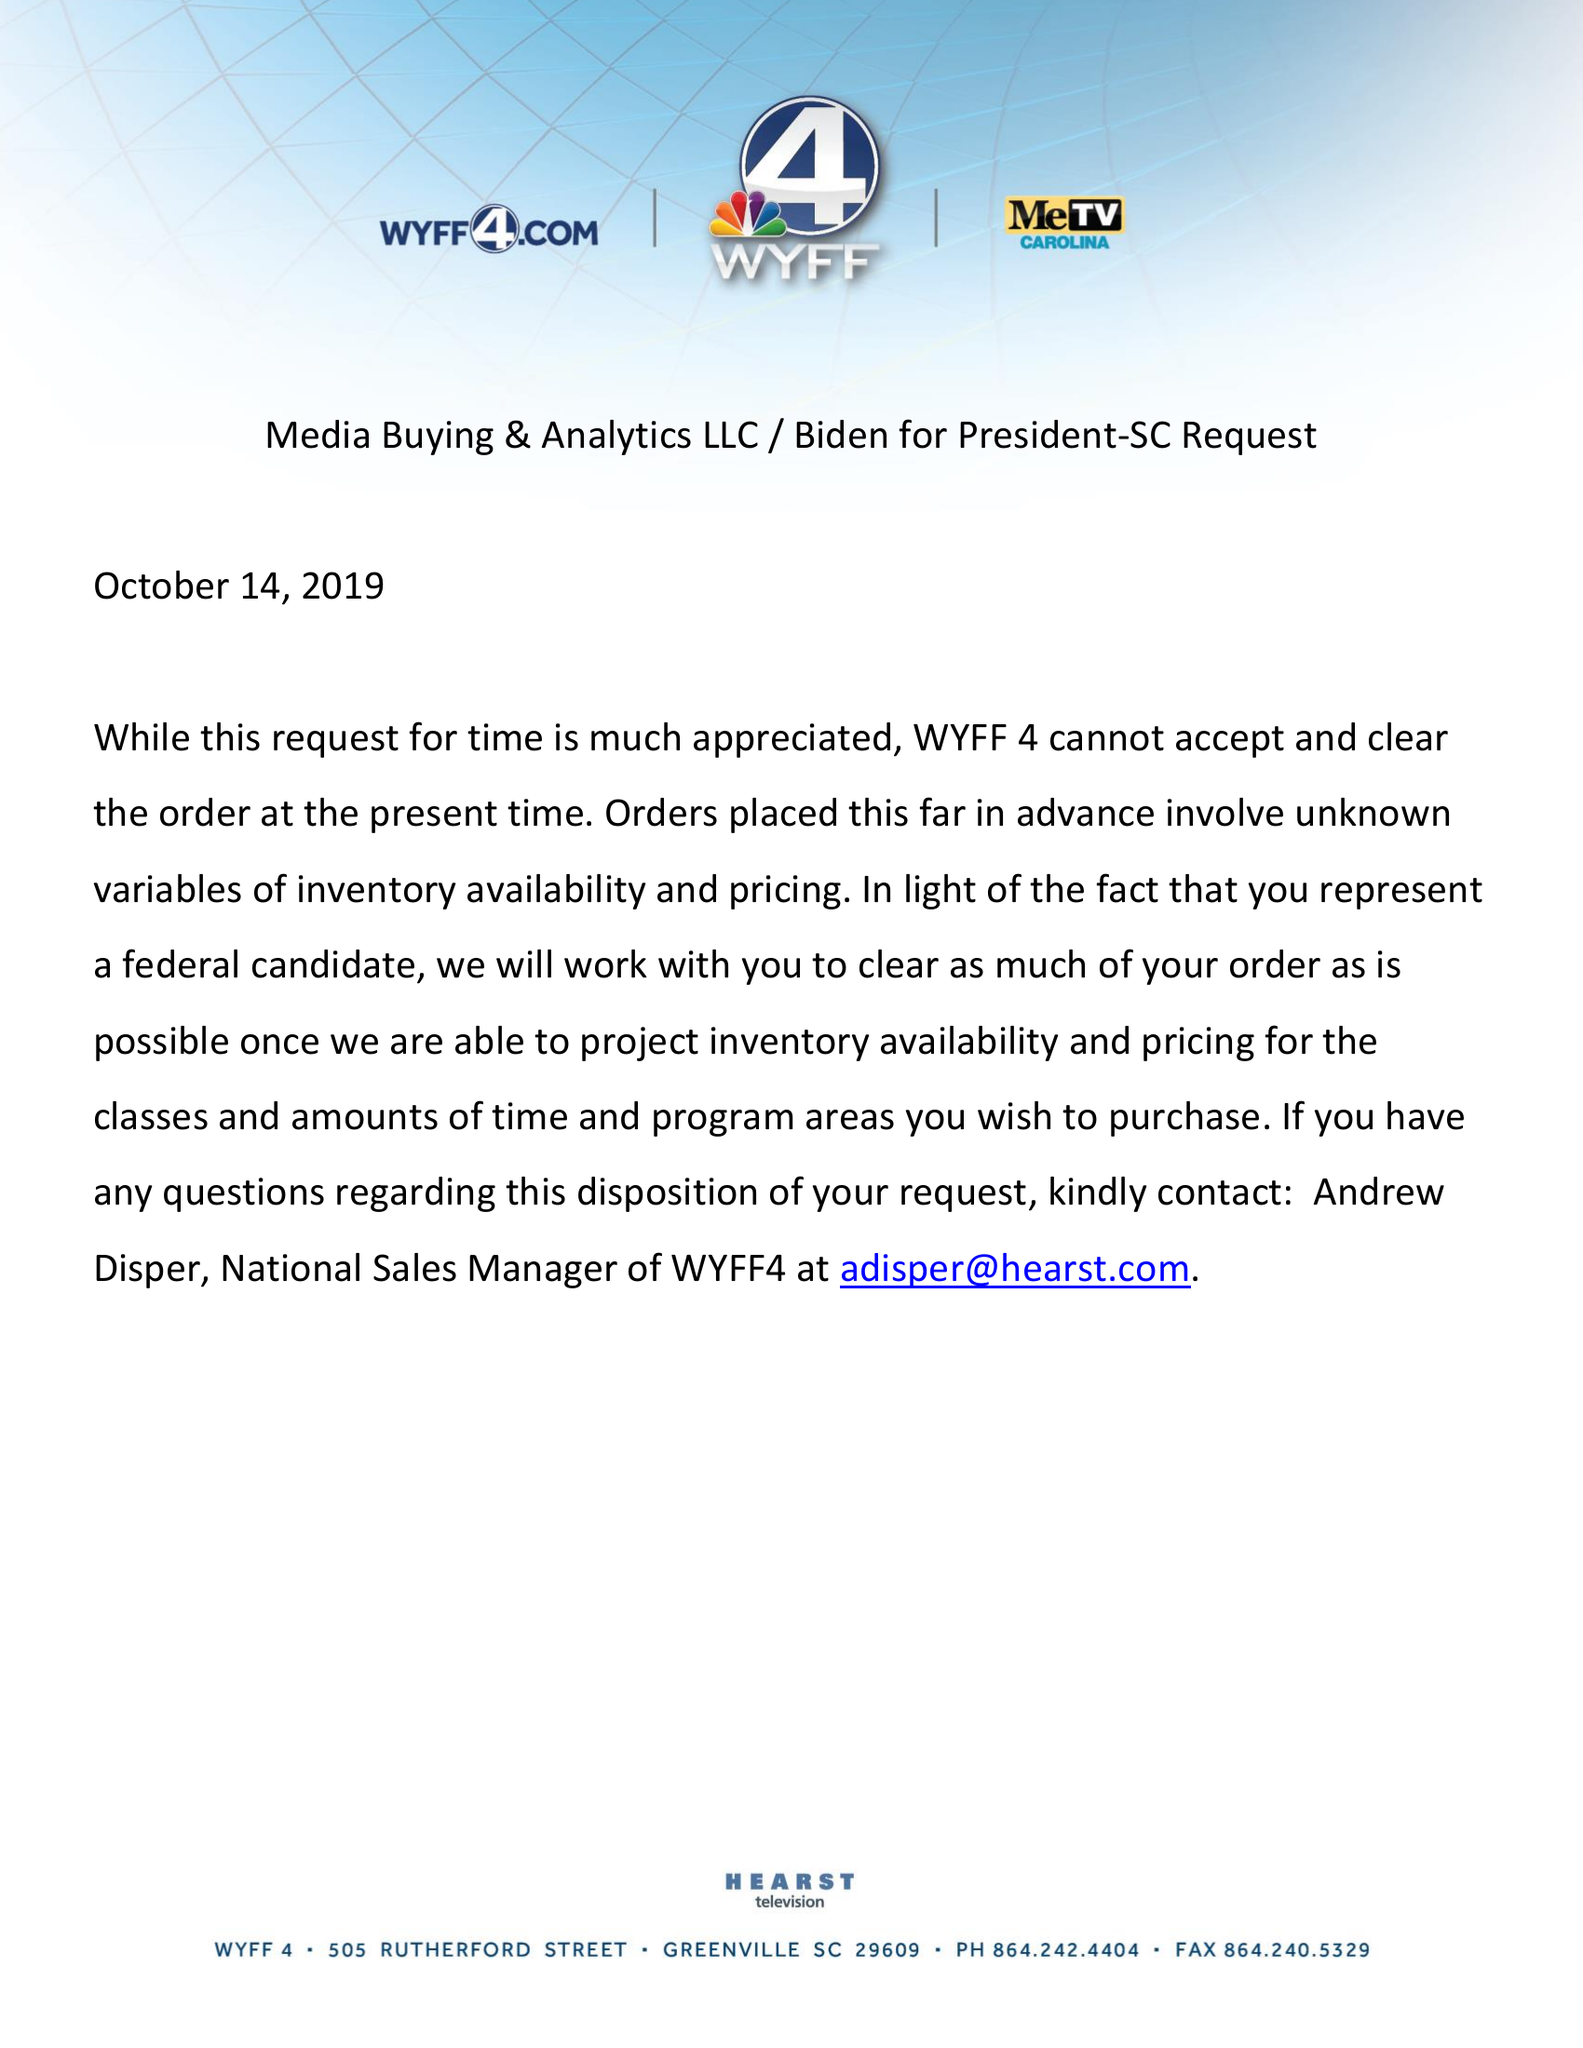What is the value for the flight_from?
Answer the question using a single word or phrase. None 